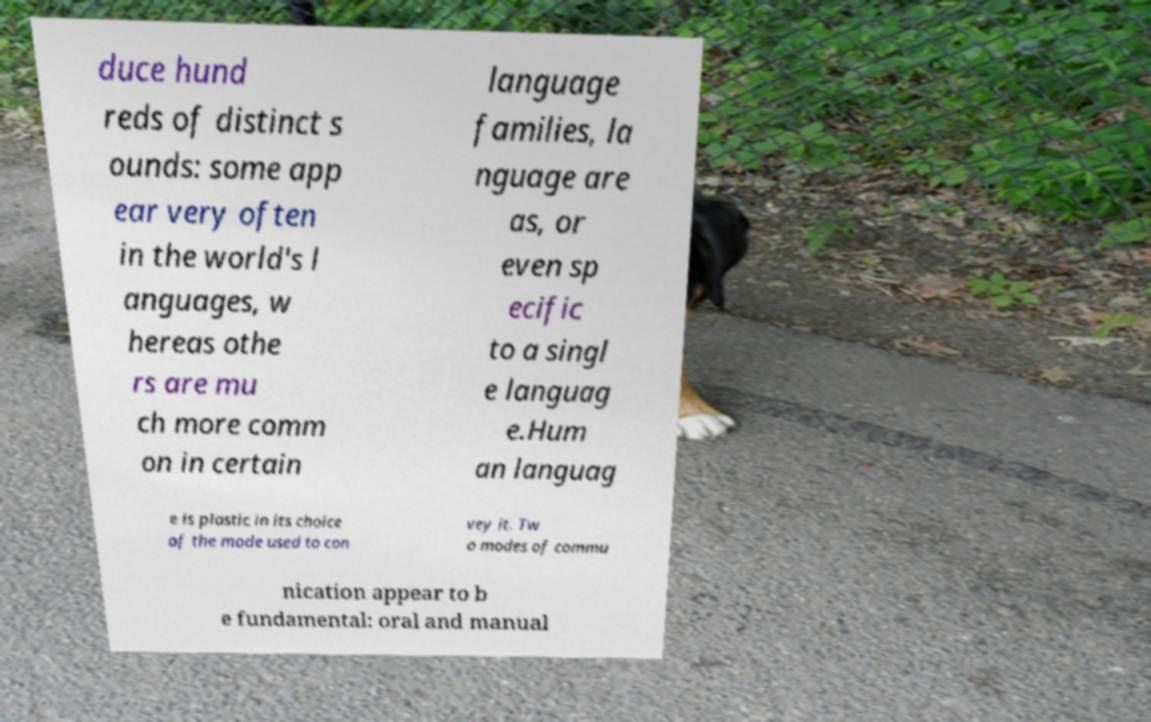I need the written content from this picture converted into text. Can you do that? duce hund reds of distinct s ounds: some app ear very often in the world's l anguages, w hereas othe rs are mu ch more comm on in certain language families, la nguage are as, or even sp ecific to a singl e languag e.Hum an languag e is plastic in its choice of the mode used to con vey it. Tw o modes of commu nication appear to b e fundamental: oral and manual 